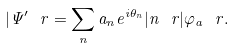Convert formula to latex. <formula><loc_0><loc_0><loc_500><loc_500>| \Psi ^ { \prime } \ r = \sum _ { n } a _ { n } e ^ { i \theta _ { n } } | n \ r | \varphi _ { a } \ r .</formula> 